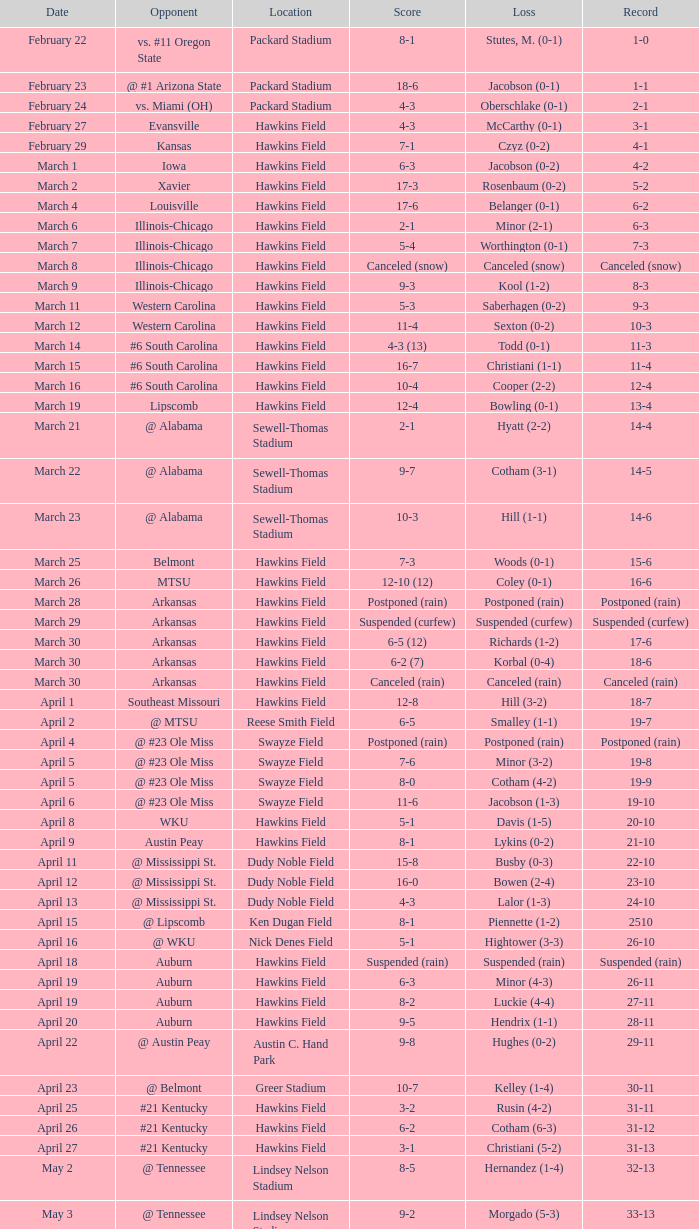Can you parse all the data within this table? {'header': ['Date', 'Opponent', 'Location', 'Score', 'Loss', 'Record'], 'rows': [['February 22', 'vs. #11 Oregon State', 'Packard Stadium', '8-1', 'Stutes, M. (0-1)', '1-0'], ['February 23', '@ #1 Arizona State', 'Packard Stadium', '18-6', 'Jacobson (0-1)', '1-1'], ['February 24', 'vs. Miami (OH)', 'Packard Stadium', '4-3', 'Oberschlake (0-1)', '2-1'], ['February 27', 'Evansville', 'Hawkins Field', '4-3', 'McCarthy (0-1)', '3-1'], ['February 29', 'Kansas', 'Hawkins Field', '7-1', 'Czyz (0-2)', '4-1'], ['March 1', 'Iowa', 'Hawkins Field', '6-3', 'Jacobson (0-2)', '4-2'], ['March 2', 'Xavier', 'Hawkins Field', '17-3', 'Rosenbaum (0-2)', '5-2'], ['March 4', 'Louisville', 'Hawkins Field', '17-6', 'Belanger (0-1)', '6-2'], ['March 6', 'Illinois-Chicago', 'Hawkins Field', '2-1', 'Minor (2-1)', '6-3'], ['March 7', 'Illinois-Chicago', 'Hawkins Field', '5-4', 'Worthington (0-1)', '7-3'], ['March 8', 'Illinois-Chicago', 'Hawkins Field', 'Canceled (snow)', 'Canceled (snow)', 'Canceled (snow)'], ['March 9', 'Illinois-Chicago', 'Hawkins Field', '9-3', 'Kool (1-2)', '8-3'], ['March 11', 'Western Carolina', 'Hawkins Field', '5-3', 'Saberhagen (0-2)', '9-3'], ['March 12', 'Western Carolina', 'Hawkins Field', '11-4', 'Sexton (0-2)', '10-3'], ['March 14', '#6 South Carolina', 'Hawkins Field', '4-3 (13)', 'Todd (0-1)', '11-3'], ['March 15', '#6 South Carolina', 'Hawkins Field', '16-7', 'Christiani (1-1)', '11-4'], ['March 16', '#6 South Carolina', 'Hawkins Field', '10-4', 'Cooper (2-2)', '12-4'], ['March 19', 'Lipscomb', 'Hawkins Field', '12-4', 'Bowling (0-1)', '13-4'], ['March 21', '@ Alabama', 'Sewell-Thomas Stadium', '2-1', 'Hyatt (2-2)', '14-4'], ['March 22', '@ Alabama', 'Sewell-Thomas Stadium', '9-7', 'Cotham (3-1)', '14-5'], ['March 23', '@ Alabama', 'Sewell-Thomas Stadium', '10-3', 'Hill (1-1)', '14-6'], ['March 25', 'Belmont', 'Hawkins Field', '7-3', 'Woods (0-1)', '15-6'], ['March 26', 'MTSU', 'Hawkins Field', '12-10 (12)', 'Coley (0-1)', '16-6'], ['March 28', 'Arkansas', 'Hawkins Field', 'Postponed (rain)', 'Postponed (rain)', 'Postponed (rain)'], ['March 29', 'Arkansas', 'Hawkins Field', 'Suspended (curfew)', 'Suspended (curfew)', 'Suspended (curfew)'], ['March 30', 'Arkansas', 'Hawkins Field', '6-5 (12)', 'Richards (1-2)', '17-6'], ['March 30', 'Arkansas', 'Hawkins Field', '6-2 (7)', 'Korbal (0-4)', '18-6'], ['March 30', 'Arkansas', 'Hawkins Field', 'Canceled (rain)', 'Canceled (rain)', 'Canceled (rain)'], ['April 1', 'Southeast Missouri', 'Hawkins Field', '12-8', 'Hill (3-2)', '18-7'], ['April 2', '@ MTSU', 'Reese Smith Field', '6-5', 'Smalley (1-1)', '19-7'], ['April 4', '@ #23 Ole Miss', 'Swayze Field', 'Postponed (rain)', 'Postponed (rain)', 'Postponed (rain)'], ['April 5', '@ #23 Ole Miss', 'Swayze Field', '7-6', 'Minor (3-2)', '19-8'], ['April 5', '@ #23 Ole Miss', 'Swayze Field', '8-0', 'Cotham (4-2)', '19-9'], ['April 6', '@ #23 Ole Miss', 'Swayze Field', '11-6', 'Jacobson (1-3)', '19-10'], ['April 8', 'WKU', 'Hawkins Field', '5-1', 'Davis (1-5)', '20-10'], ['April 9', 'Austin Peay', 'Hawkins Field', '8-1', 'Lykins (0-2)', '21-10'], ['April 11', '@ Mississippi St.', 'Dudy Noble Field', '15-8', 'Busby (0-3)', '22-10'], ['April 12', '@ Mississippi St.', 'Dudy Noble Field', '16-0', 'Bowen (2-4)', '23-10'], ['April 13', '@ Mississippi St.', 'Dudy Noble Field', '4-3', 'Lalor (1-3)', '24-10'], ['April 15', '@ Lipscomb', 'Ken Dugan Field', '8-1', 'Piennette (1-2)', '2510'], ['April 16', '@ WKU', 'Nick Denes Field', '5-1', 'Hightower (3-3)', '26-10'], ['April 18', 'Auburn', 'Hawkins Field', 'Suspended (rain)', 'Suspended (rain)', 'Suspended (rain)'], ['April 19', 'Auburn', 'Hawkins Field', '6-3', 'Minor (4-3)', '26-11'], ['April 19', 'Auburn', 'Hawkins Field', '8-2', 'Luckie (4-4)', '27-11'], ['April 20', 'Auburn', 'Hawkins Field', '9-5', 'Hendrix (1-1)', '28-11'], ['April 22', '@ Austin Peay', 'Austin C. Hand Park', '9-8', 'Hughes (0-2)', '29-11'], ['April 23', '@ Belmont', 'Greer Stadium', '10-7', 'Kelley (1-4)', '30-11'], ['April 25', '#21 Kentucky', 'Hawkins Field', '3-2', 'Rusin (4-2)', '31-11'], ['April 26', '#21 Kentucky', 'Hawkins Field', '6-2', 'Cotham (6-3)', '31-12'], ['April 27', '#21 Kentucky', 'Hawkins Field', '3-1', 'Christiani (5-2)', '31-13'], ['May 2', '@ Tennessee', 'Lindsey Nelson Stadium', '8-5', 'Hernandez (1-4)', '32-13'], ['May 3', '@ Tennessee', 'Lindsey Nelson Stadium', '9-2', 'Morgado (5-3)', '33-13'], ['May 4', '@ Tennessee', 'Lindsey Nelson Stadium', '10-8', 'Wiltz (3-2)', '34-13'], ['May 6', 'vs. Memphis', 'Pringles Park', '8-0', 'Martin (4-3)', '35-13'], ['May 7', 'Tennessee Tech', 'Hawkins Field', '7-2', 'Liberatore (1-1)', '36-13'], ['May 9', '#9 Georgia', 'Hawkins Field', '13-7', 'Holder (7-3)', '37-13'], ['May 10', '#9 Georgia', 'Hawkins Field', '4-2 (10)', 'Brewer (4-1)', '37-14'], ['May 11', '#9 Georgia', 'Hawkins Field', '12-10', 'Christiani (5-3)', '37-15'], ['May 15', '@ Florida', 'McKethan Stadium', '8-6', 'Brewer (4-2)', '37-16'], ['May 16', '@ Florida', 'McKethan Stadium', '5-4', 'Cotham (7-4)', '37-17'], ['May 17', '@ Florida', 'McKethan Stadium', '13-12 (11)', 'Jacobson (1-4)', '37-18']]} What was the location of the game when the record was 12-4? Hawkins Field. 